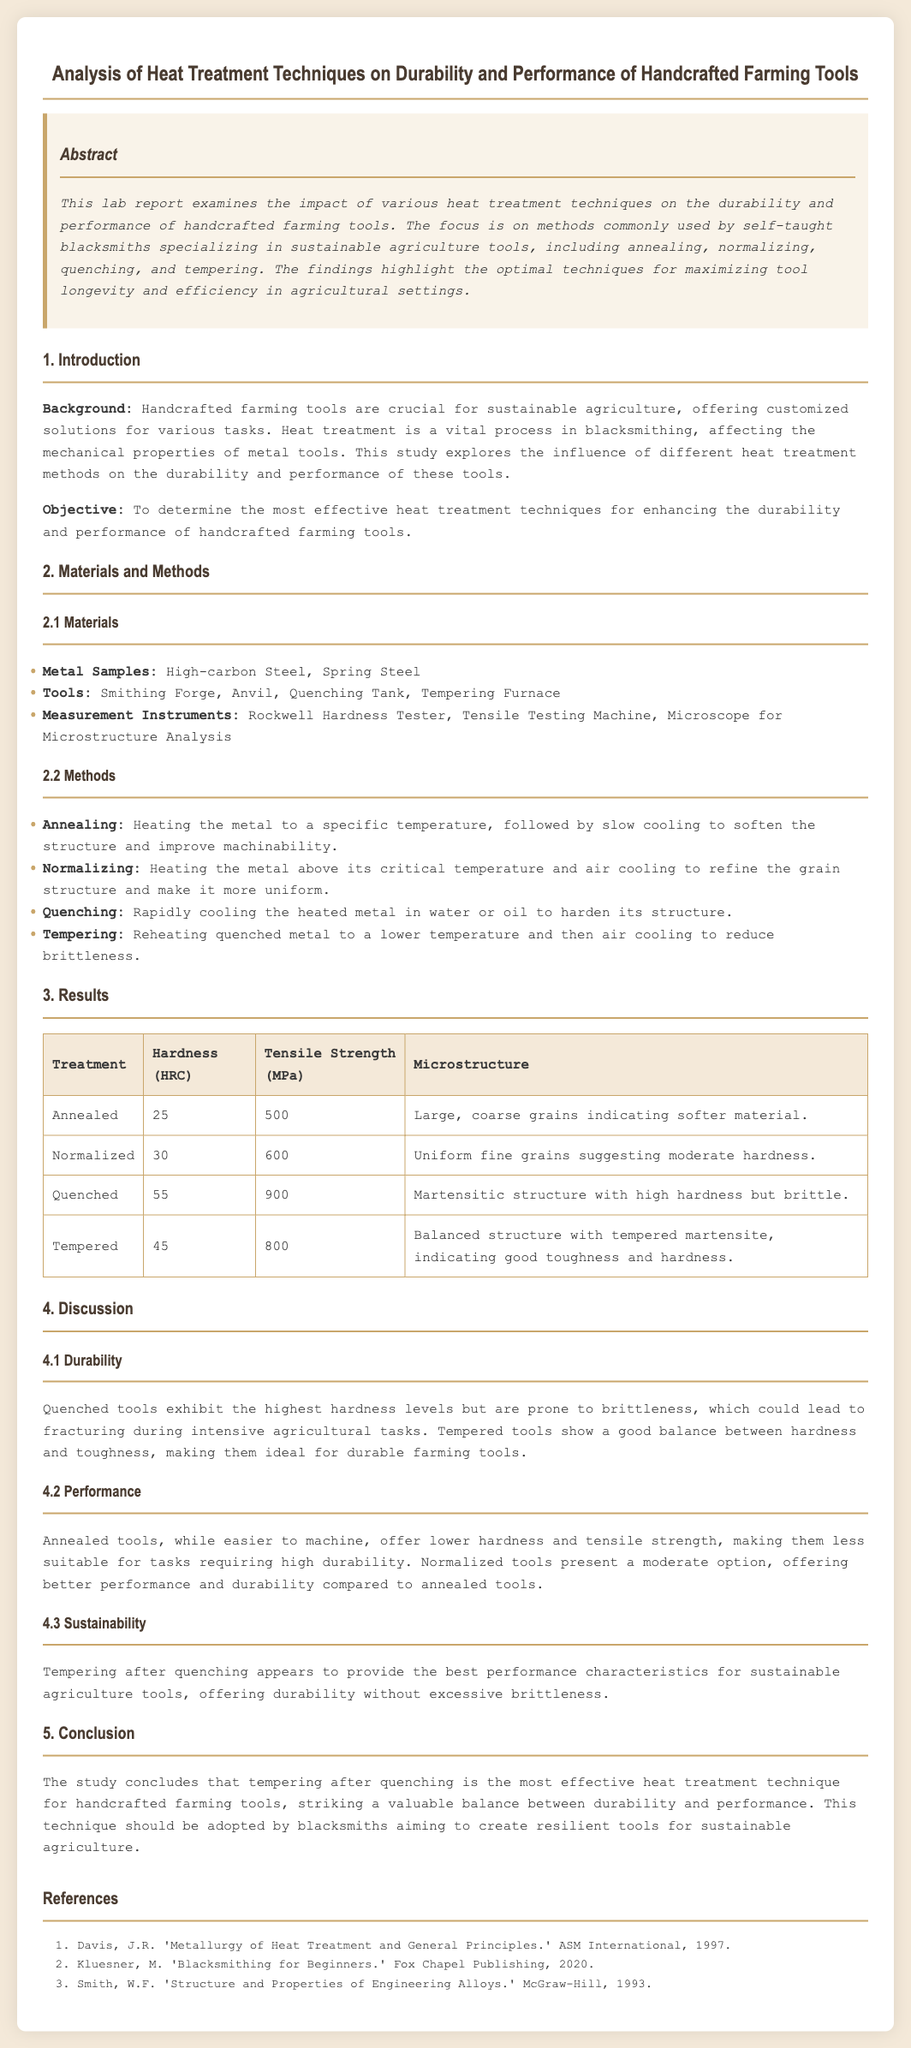what is the title of the lab report? The title of the lab report is prominently displayed at the beginning of the document.
Answer: Analysis of Heat Treatment Techniques on Durability and Performance of Handcrafted Farming Tools what is the hardness of quenched tools? The hardness values are presented in a table within the results section.
Answer: 55 what are the materials used in the study? The materials section lists specific metals and tools that were utilized during the experiment.
Answer: High-carbon Steel, Spring Steel which heat treatment technique provides the best balance of durability and performance? The conclusion summarizes the findings and mentions the most effective technique.
Answer: Tempering after quenching what is the tensile strength of normalized tools? The tensile strengths for each treatment are included in the results table.
Answer: 600 how does the microstructure of annealed tools appear? The microstructure description is provided in the results for each treatment type.
Answer: Large, coarse grains indicating softer material which reference is authored by J.R. Davis? The references list provides information on the authors and titles of the literature used in the report.
Answer: Metallurgy of Heat Treatment and General Principles what is the primary objective of the study? The objective is clearly stated in the introduction section of the document.
Answer: To determine the most effective heat treatment techniques for enhancing the durability and performance of handcrafted farming tools 